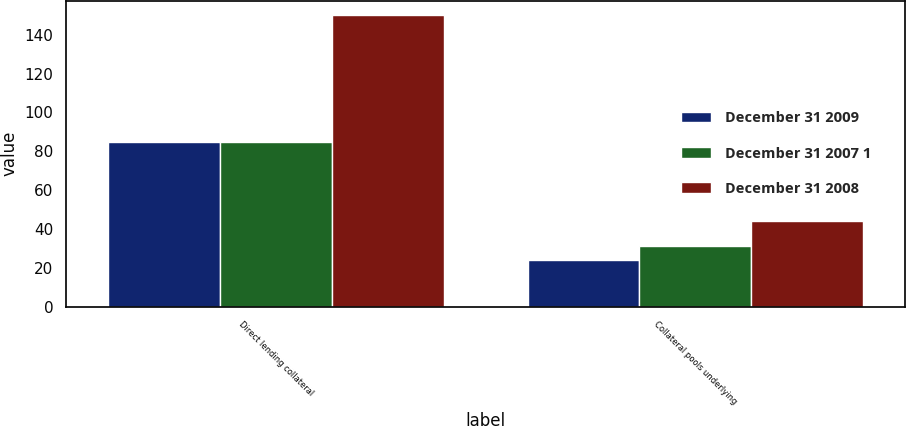Convert chart. <chart><loc_0><loc_0><loc_500><loc_500><stacked_bar_chart><ecel><fcel>Direct lending collateral<fcel>Collateral pools underlying<nl><fcel>December 31 2009<fcel>85<fcel>24<nl><fcel>December 31 2007 1<fcel>85<fcel>31<nl><fcel>December 31 2008<fcel>150<fcel>44<nl></chart> 